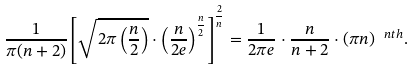Convert formula to latex. <formula><loc_0><loc_0><loc_500><loc_500>\frac { 1 } { \pi ( n + 2 ) } \left [ \sqrt { 2 \pi \left ( \frac { n } { 2 } \right ) } \cdot \left ( \frac { n } { 2 e } \right ) ^ { \frac { n } { 2 } } \right ] ^ { \frac { 2 } { n } } = \frac { 1 } { 2 \pi e } \cdot \frac { n } { n + 2 } \cdot ( \pi n ) ^ { \ n t h } .</formula> 